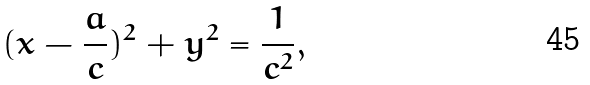<formula> <loc_0><loc_0><loc_500><loc_500>( x - \frac { a } { c } ) ^ { 2 } + y ^ { 2 } = \frac { 1 } { c ^ { 2 } } ,</formula> 